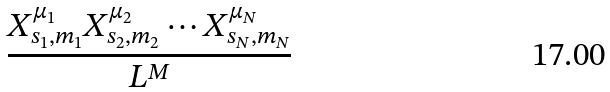Convert formula to latex. <formula><loc_0><loc_0><loc_500><loc_500>\frac { X ^ { \mu _ { 1 } } _ { s _ { 1 } , m _ { 1 } } X ^ { \mu _ { 2 } } _ { s _ { 2 } , m _ { 2 } } \cdots X ^ { \mu _ { N } } _ { s _ { N } , m _ { N } } } { L ^ { M } }</formula> 